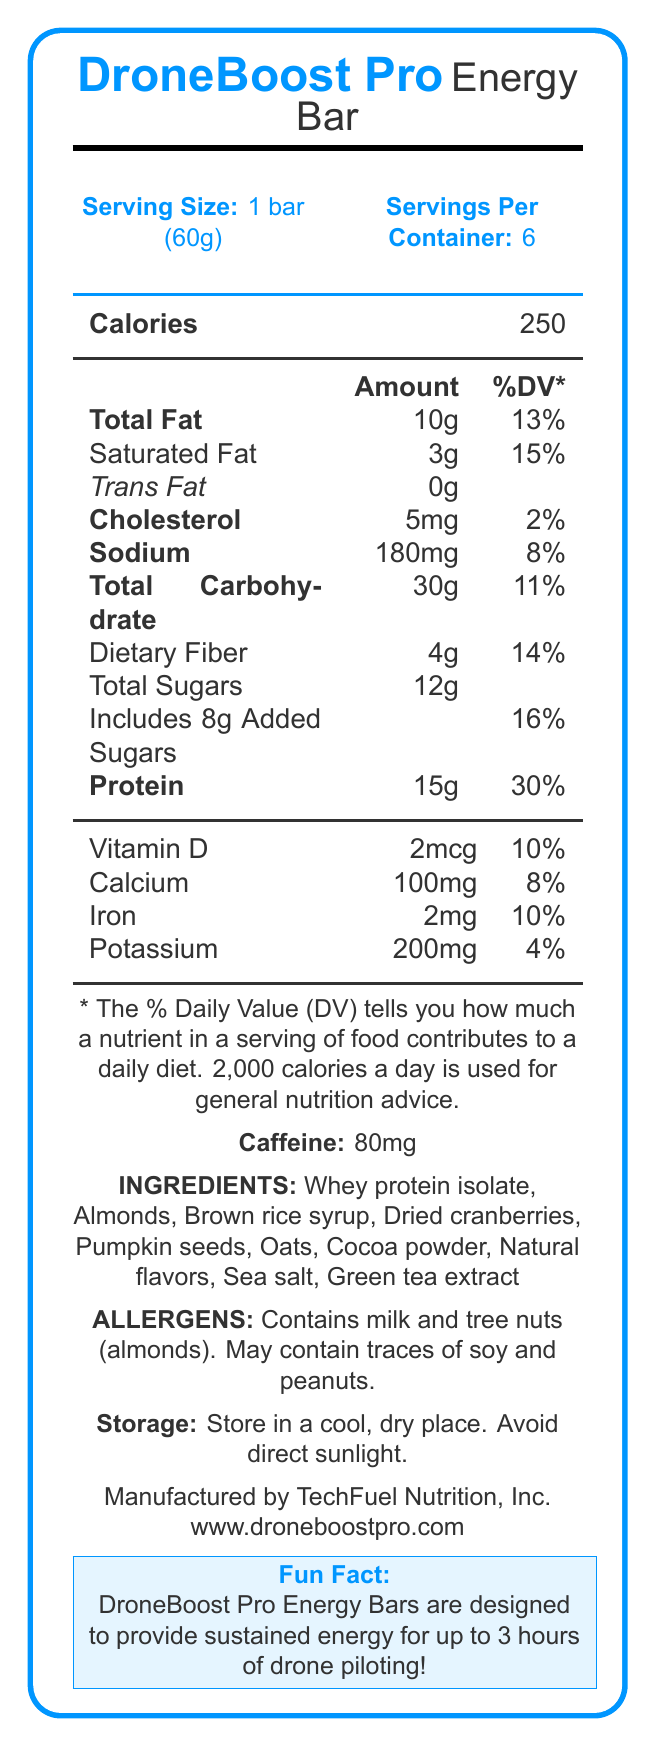What is the serving size of the DroneBoost Pro Energy Bar? The document specifies the serving size as "1 bar (60g)".
Answer: 1 bar (60g) How many servings are there per container? The document states there are 6 servings per container.
Answer: 6 How many calories are in one serving of the DroneBoost Pro Energy Bar? The number of calories per serving is listed as 250.
Answer: 250 What is the amount of protein in one serving? The protein amount per serving is shown as 15g.
Answer: 15g Which ingredient is listed first in the ingredients section? The first ingredient listed is Whey protein isolate.
Answer: Whey protein isolate Does the DroneBoost Pro Energy Bar contain any cholesterol? The document mentions that the bar contains 5mg of cholesterol per serving.
Answer: Yes How much sodium does one serving of the bar contain? The sodium content per serving is listed as 180mg.
Answer: 180mg What percentage of the daily value of calcium does one energy bar provide? The document states that one bar provides 8% of the daily value for calcium.
Answer: 8% Which allergens are mentioned in the document? A. Soy and Peanuts B. Milk and Tree Nuts C. Wheat and Soy The document specifies that the bar contains milk and tree nuts (almonds) and may contain traces of soy and peanuts.
Answer: B What is the amount of added sugars in the DroneBoost Pro Energy Bar? The amount of added sugars is listed as "Includes 8g Added Sugars".
Answer: 8g How much caffeine is in the DroneBoost Pro Energy Bar? The document states the caffeine content is 80mg.
Answer: 80mg Which company manufactures the DroneBoost Pro Energy Bar? A. DroneFuel Inc. B. NutritionTech Co. C. TechFuel Nutrition, Inc. D. BoostDrone LLC The manufacturer is listed as TechFuel Nutrition, Inc.
Answer: C Describe the main purpose of the DroneBoost Pro Energy Bar according to the document. The document mentions the "fun fact" that the bars are designed to provide sustained energy for up to 3 hours of drone piloting, indicating its primary purpose.
Answer: To provide sustained energy for up to 3 hours of drone piloting Does the DroneBoost Pro Energy Bar contain any trans fats? The document lists the trans fat content as 0g, indicating it does not contain any trans fats.
Answer: No What daily value percentage of dietary fiber does one bar provide? The document states that one bar provides 14% of the daily value for dietary fiber.
Answer: 14% What are the storage instructions for the DroneBoost Pro Energy Bar? The document provides these specific storage instructions.
Answer: Store in a cool, dry place. Avoid direct sunlight. How many milligrams of potassium does one bar contain? The potassium content per bar is listed as 200mg.
Answer: 200mg What is the calorie content for the entire container of DroneBoost Pro Energy Bars? The document provides the calorie content per bar but does not specify the total calorie content for the entire container directly.
Answer: Not enough information 